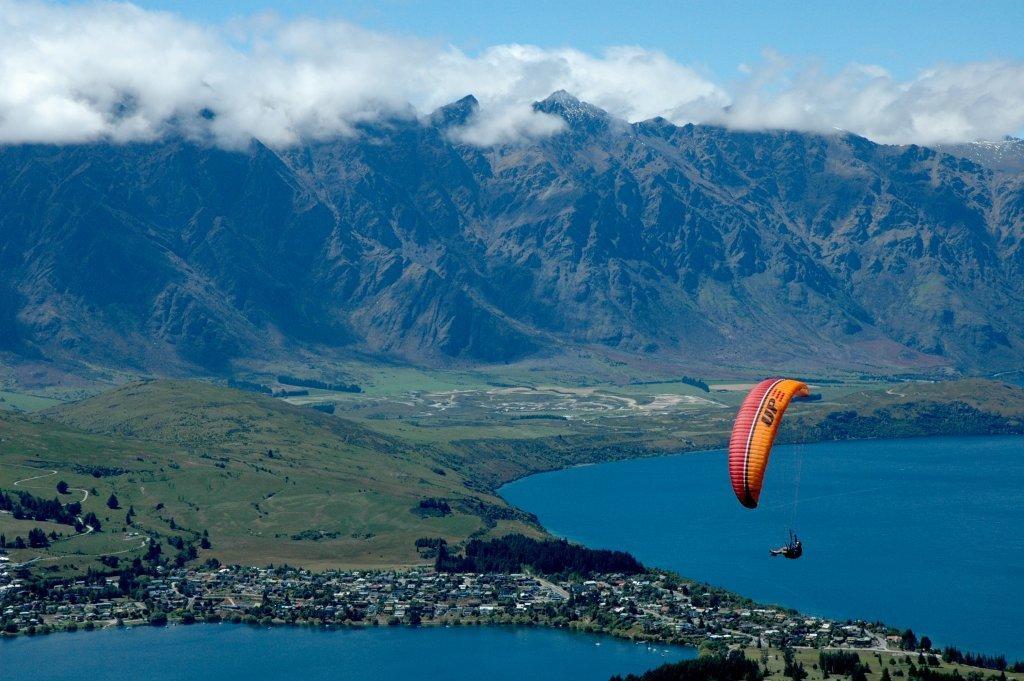Can you describe this image briefly? In the middle of the image a man is doing paragliding. At the bottom of the image there is water and there are some trees and buildings. At the top of the image there are some hills and clouds and sky. 